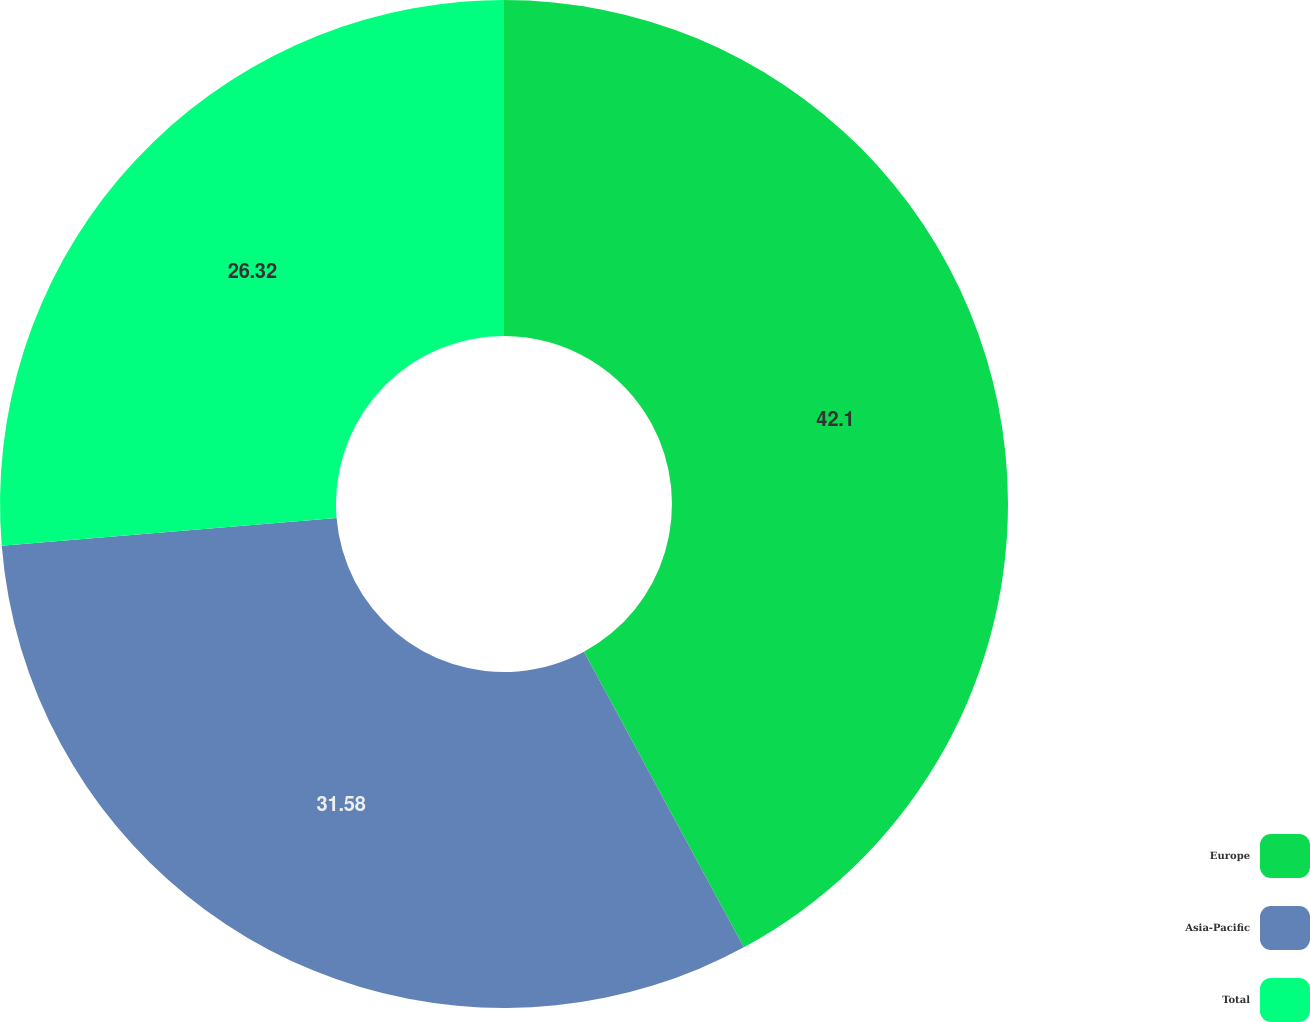Convert chart to OTSL. <chart><loc_0><loc_0><loc_500><loc_500><pie_chart><fcel>Europe<fcel>Asia-Pacific<fcel>Total<nl><fcel>42.11%<fcel>31.58%<fcel>26.32%<nl></chart> 